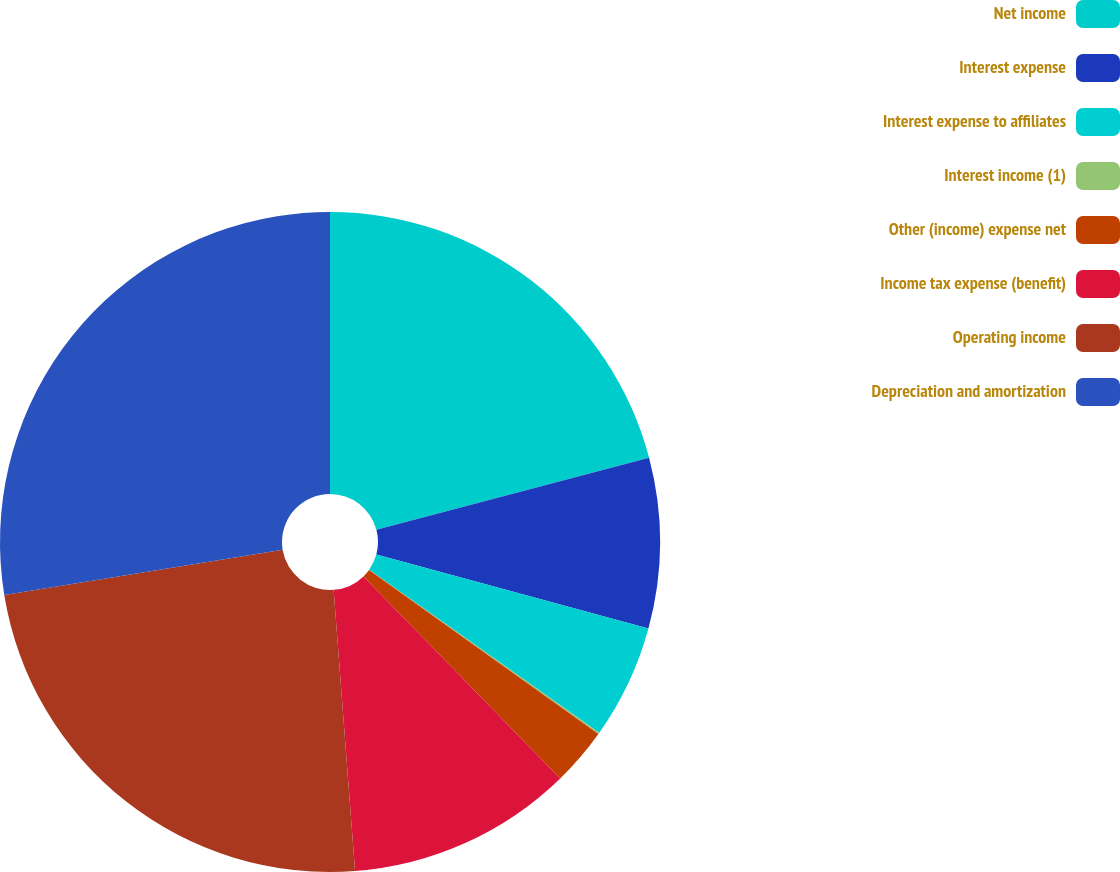Convert chart to OTSL. <chart><loc_0><loc_0><loc_500><loc_500><pie_chart><fcel>Net income<fcel>Interest expense<fcel>Interest expense to affiliates<fcel>Interest income (1)<fcel>Other (income) expense net<fcel>Income tax expense (benefit)<fcel>Operating income<fcel>Depreciation and amortization<nl><fcel>20.9%<fcel>8.33%<fcel>5.58%<fcel>0.08%<fcel>2.83%<fcel>11.08%<fcel>23.65%<fcel>27.57%<nl></chart> 